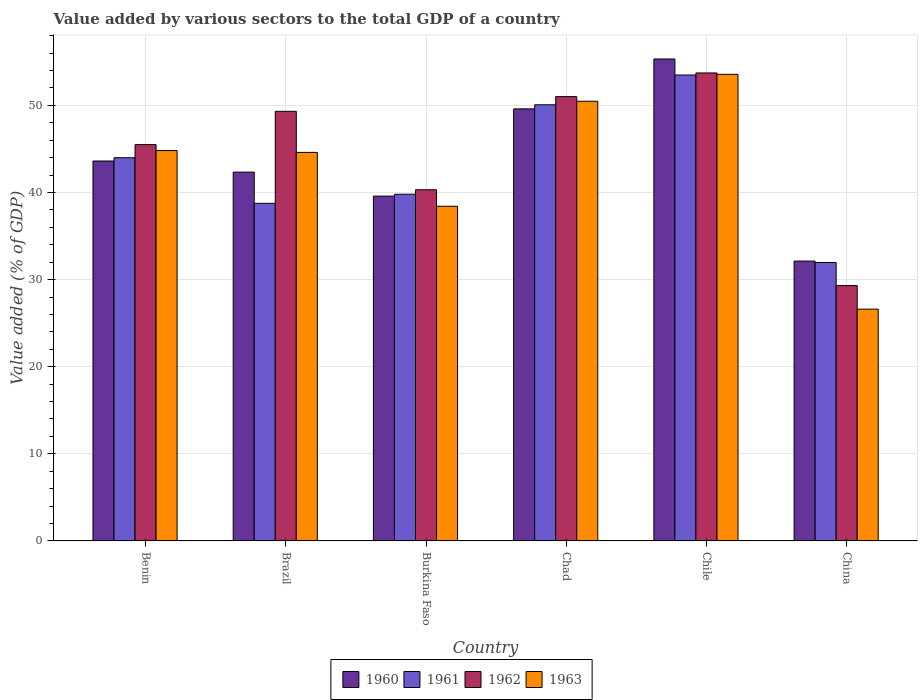How many different coloured bars are there?
Provide a succinct answer. 4. How many groups of bars are there?
Offer a very short reply. 6. Are the number of bars per tick equal to the number of legend labels?
Provide a short and direct response. Yes. Are the number of bars on each tick of the X-axis equal?
Offer a very short reply. Yes. How many bars are there on the 4th tick from the left?
Keep it short and to the point. 4. How many bars are there on the 4th tick from the right?
Your answer should be compact. 4. What is the label of the 4th group of bars from the left?
Provide a short and direct response. Chad. What is the value added by various sectors to the total GDP in 1963 in Benin?
Provide a succinct answer. 44.81. Across all countries, what is the maximum value added by various sectors to the total GDP in 1962?
Your answer should be very brief. 53.72. Across all countries, what is the minimum value added by various sectors to the total GDP in 1962?
Give a very brief answer. 29.31. In which country was the value added by various sectors to the total GDP in 1960 maximum?
Your response must be concise. Chile. What is the total value added by various sectors to the total GDP in 1962 in the graph?
Your answer should be compact. 269.18. What is the difference between the value added by various sectors to the total GDP in 1961 in Brazil and that in China?
Offer a very short reply. 6.79. What is the difference between the value added by various sectors to the total GDP in 1960 in Chad and the value added by various sectors to the total GDP in 1963 in Burkina Faso?
Provide a short and direct response. 11.18. What is the average value added by various sectors to the total GDP in 1960 per country?
Provide a short and direct response. 43.77. What is the difference between the value added by various sectors to the total GDP of/in 1962 and value added by various sectors to the total GDP of/in 1960 in Brazil?
Keep it short and to the point. 6.98. In how many countries, is the value added by various sectors to the total GDP in 1962 greater than 44 %?
Offer a very short reply. 4. What is the ratio of the value added by various sectors to the total GDP in 1961 in Brazil to that in Chad?
Keep it short and to the point. 0.77. Is the value added by various sectors to the total GDP in 1963 in Benin less than that in Brazil?
Ensure brevity in your answer.  No. Is the difference between the value added by various sectors to the total GDP in 1962 in Brazil and China greater than the difference between the value added by various sectors to the total GDP in 1960 in Brazil and China?
Offer a terse response. Yes. What is the difference between the highest and the second highest value added by various sectors to the total GDP in 1963?
Keep it short and to the point. 5.66. What is the difference between the highest and the lowest value added by various sectors to the total GDP in 1960?
Offer a very short reply. 23.2. In how many countries, is the value added by various sectors to the total GDP in 1960 greater than the average value added by various sectors to the total GDP in 1960 taken over all countries?
Ensure brevity in your answer.  2. Is the sum of the value added by various sectors to the total GDP in 1962 in Brazil and Chile greater than the maximum value added by various sectors to the total GDP in 1961 across all countries?
Your answer should be very brief. Yes. What does the 4th bar from the left in Brazil represents?
Your answer should be very brief. 1963. How many bars are there?
Give a very brief answer. 24. Are all the bars in the graph horizontal?
Provide a short and direct response. No. How many countries are there in the graph?
Provide a short and direct response. 6. What is the difference between two consecutive major ticks on the Y-axis?
Keep it short and to the point. 10. Where does the legend appear in the graph?
Provide a succinct answer. Bottom center. How many legend labels are there?
Your answer should be compact. 4. How are the legend labels stacked?
Your response must be concise. Horizontal. What is the title of the graph?
Your answer should be very brief. Value added by various sectors to the total GDP of a country. What is the label or title of the X-axis?
Give a very brief answer. Country. What is the label or title of the Y-axis?
Your answer should be compact. Value added (% of GDP). What is the Value added (% of GDP) in 1960 in Benin?
Provide a short and direct response. 43.62. What is the Value added (% of GDP) in 1961 in Benin?
Give a very brief answer. 43.99. What is the Value added (% of GDP) of 1962 in Benin?
Your answer should be very brief. 45.5. What is the Value added (% of GDP) of 1963 in Benin?
Ensure brevity in your answer.  44.81. What is the Value added (% of GDP) of 1960 in Brazil?
Give a very brief answer. 42.34. What is the Value added (% of GDP) of 1961 in Brazil?
Your response must be concise. 38.76. What is the Value added (% of GDP) in 1962 in Brazil?
Give a very brief answer. 49.32. What is the Value added (% of GDP) of 1963 in Brazil?
Provide a succinct answer. 44.6. What is the Value added (% of GDP) of 1960 in Burkina Faso?
Make the answer very short. 39.59. What is the Value added (% of GDP) in 1961 in Burkina Faso?
Provide a succinct answer. 39.8. What is the Value added (% of GDP) of 1962 in Burkina Faso?
Provide a succinct answer. 40.31. What is the Value added (% of GDP) of 1963 in Burkina Faso?
Your answer should be compact. 38.42. What is the Value added (% of GDP) of 1960 in Chad?
Provide a short and direct response. 49.6. What is the Value added (% of GDP) of 1961 in Chad?
Give a very brief answer. 50.07. What is the Value added (% of GDP) of 1962 in Chad?
Offer a terse response. 51.01. What is the Value added (% of GDP) in 1963 in Chad?
Your answer should be compact. 50.47. What is the Value added (% of GDP) in 1960 in Chile?
Make the answer very short. 55.33. What is the Value added (% of GDP) in 1961 in Chile?
Your response must be concise. 53.49. What is the Value added (% of GDP) in 1962 in Chile?
Offer a very short reply. 53.72. What is the Value added (% of GDP) of 1963 in Chile?
Make the answer very short. 53.57. What is the Value added (% of GDP) of 1960 in China?
Your response must be concise. 32.13. What is the Value added (% of GDP) in 1961 in China?
Your response must be concise. 31.97. What is the Value added (% of GDP) of 1962 in China?
Provide a succinct answer. 29.31. What is the Value added (% of GDP) of 1963 in China?
Provide a short and direct response. 26.61. Across all countries, what is the maximum Value added (% of GDP) of 1960?
Provide a short and direct response. 55.33. Across all countries, what is the maximum Value added (% of GDP) of 1961?
Make the answer very short. 53.49. Across all countries, what is the maximum Value added (% of GDP) of 1962?
Make the answer very short. 53.72. Across all countries, what is the maximum Value added (% of GDP) in 1963?
Give a very brief answer. 53.57. Across all countries, what is the minimum Value added (% of GDP) in 1960?
Offer a very short reply. 32.13. Across all countries, what is the minimum Value added (% of GDP) in 1961?
Your answer should be compact. 31.97. Across all countries, what is the minimum Value added (% of GDP) in 1962?
Your response must be concise. 29.31. Across all countries, what is the minimum Value added (% of GDP) in 1963?
Your response must be concise. 26.61. What is the total Value added (% of GDP) of 1960 in the graph?
Provide a short and direct response. 262.6. What is the total Value added (% of GDP) in 1961 in the graph?
Your answer should be compact. 258.07. What is the total Value added (% of GDP) of 1962 in the graph?
Your response must be concise. 269.18. What is the total Value added (% of GDP) in 1963 in the graph?
Provide a short and direct response. 258.49. What is the difference between the Value added (% of GDP) of 1960 in Benin and that in Brazil?
Offer a very short reply. 1.27. What is the difference between the Value added (% of GDP) in 1961 in Benin and that in Brazil?
Make the answer very short. 5.23. What is the difference between the Value added (% of GDP) in 1962 in Benin and that in Brazil?
Ensure brevity in your answer.  -3.82. What is the difference between the Value added (% of GDP) in 1963 in Benin and that in Brazil?
Provide a succinct answer. 0.21. What is the difference between the Value added (% of GDP) of 1960 in Benin and that in Burkina Faso?
Ensure brevity in your answer.  4.03. What is the difference between the Value added (% of GDP) in 1961 in Benin and that in Burkina Faso?
Offer a terse response. 4.19. What is the difference between the Value added (% of GDP) of 1962 in Benin and that in Burkina Faso?
Make the answer very short. 5.19. What is the difference between the Value added (% of GDP) of 1963 in Benin and that in Burkina Faso?
Provide a short and direct response. 6.39. What is the difference between the Value added (% of GDP) of 1960 in Benin and that in Chad?
Offer a terse response. -5.98. What is the difference between the Value added (% of GDP) of 1961 in Benin and that in Chad?
Your response must be concise. -6.08. What is the difference between the Value added (% of GDP) in 1962 in Benin and that in Chad?
Keep it short and to the point. -5.51. What is the difference between the Value added (% of GDP) of 1963 in Benin and that in Chad?
Provide a short and direct response. -5.66. What is the difference between the Value added (% of GDP) in 1960 in Benin and that in Chile?
Provide a succinct answer. -11.71. What is the difference between the Value added (% of GDP) of 1961 in Benin and that in Chile?
Your response must be concise. -9.49. What is the difference between the Value added (% of GDP) of 1962 in Benin and that in Chile?
Ensure brevity in your answer.  -8.22. What is the difference between the Value added (% of GDP) of 1963 in Benin and that in Chile?
Offer a very short reply. -8.75. What is the difference between the Value added (% of GDP) of 1960 in Benin and that in China?
Your response must be concise. 11.49. What is the difference between the Value added (% of GDP) in 1961 in Benin and that in China?
Provide a short and direct response. 12.03. What is the difference between the Value added (% of GDP) in 1962 in Benin and that in China?
Your answer should be compact. 16.19. What is the difference between the Value added (% of GDP) of 1963 in Benin and that in China?
Offer a very short reply. 18.2. What is the difference between the Value added (% of GDP) of 1960 in Brazil and that in Burkina Faso?
Ensure brevity in your answer.  2.75. What is the difference between the Value added (% of GDP) of 1961 in Brazil and that in Burkina Faso?
Give a very brief answer. -1.04. What is the difference between the Value added (% of GDP) of 1962 in Brazil and that in Burkina Faso?
Your answer should be compact. 9.01. What is the difference between the Value added (% of GDP) of 1963 in Brazil and that in Burkina Faso?
Keep it short and to the point. 6.19. What is the difference between the Value added (% of GDP) of 1960 in Brazil and that in Chad?
Keep it short and to the point. -7.26. What is the difference between the Value added (% of GDP) of 1961 in Brazil and that in Chad?
Offer a terse response. -11.31. What is the difference between the Value added (% of GDP) of 1962 in Brazil and that in Chad?
Ensure brevity in your answer.  -1.69. What is the difference between the Value added (% of GDP) of 1963 in Brazil and that in Chad?
Keep it short and to the point. -5.87. What is the difference between the Value added (% of GDP) of 1960 in Brazil and that in Chile?
Make the answer very short. -12.99. What is the difference between the Value added (% of GDP) in 1961 in Brazil and that in Chile?
Provide a succinct answer. -14.73. What is the difference between the Value added (% of GDP) of 1962 in Brazil and that in Chile?
Ensure brevity in your answer.  -4.4. What is the difference between the Value added (% of GDP) in 1963 in Brazil and that in Chile?
Ensure brevity in your answer.  -8.96. What is the difference between the Value added (% of GDP) of 1960 in Brazil and that in China?
Make the answer very short. 10.21. What is the difference between the Value added (% of GDP) in 1961 in Brazil and that in China?
Keep it short and to the point. 6.79. What is the difference between the Value added (% of GDP) of 1962 in Brazil and that in China?
Offer a terse response. 20.01. What is the difference between the Value added (% of GDP) in 1963 in Brazil and that in China?
Provide a succinct answer. 17.99. What is the difference between the Value added (% of GDP) in 1960 in Burkina Faso and that in Chad?
Offer a very short reply. -10.01. What is the difference between the Value added (% of GDP) in 1961 in Burkina Faso and that in Chad?
Your answer should be very brief. -10.27. What is the difference between the Value added (% of GDP) of 1962 in Burkina Faso and that in Chad?
Offer a very short reply. -10.69. What is the difference between the Value added (% of GDP) in 1963 in Burkina Faso and that in Chad?
Offer a very short reply. -12.06. What is the difference between the Value added (% of GDP) of 1960 in Burkina Faso and that in Chile?
Keep it short and to the point. -15.74. What is the difference between the Value added (% of GDP) of 1961 in Burkina Faso and that in Chile?
Provide a succinct answer. -13.69. What is the difference between the Value added (% of GDP) in 1962 in Burkina Faso and that in Chile?
Your response must be concise. -13.41. What is the difference between the Value added (% of GDP) of 1963 in Burkina Faso and that in Chile?
Your answer should be compact. -15.15. What is the difference between the Value added (% of GDP) of 1960 in Burkina Faso and that in China?
Keep it short and to the point. 7.46. What is the difference between the Value added (% of GDP) in 1961 in Burkina Faso and that in China?
Your response must be concise. 7.83. What is the difference between the Value added (% of GDP) of 1962 in Burkina Faso and that in China?
Your response must be concise. 11. What is the difference between the Value added (% of GDP) in 1963 in Burkina Faso and that in China?
Your answer should be very brief. 11.81. What is the difference between the Value added (% of GDP) of 1960 in Chad and that in Chile?
Your answer should be compact. -5.73. What is the difference between the Value added (% of GDP) of 1961 in Chad and that in Chile?
Offer a very short reply. -3.42. What is the difference between the Value added (% of GDP) in 1962 in Chad and that in Chile?
Offer a very short reply. -2.72. What is the difference between the Value added (% of GDP) in 1963 in Chad and that in Chile?
Ensure brevity in your answer.  -3.09. What is the difference between the Value added (% of GDP) of 1960 in Chad and that in China?
Provide a short and direct response. 17.47. What is the difference between the Value added (% of GDP) of 1961 in Chad and that in China?
Provide a short and direct response. 18.1. What is the difference between the Value added (% of GDP) of 1962 in Chad and that in China?
Offer a very short reply. 21.69. What is the difference between the Value added (% of GDP) in 1963 in Chad and that in China?
Your answer should be compact. 23.86. What is the difference between the Value added (% of GDP) of 1960 in Chile and that in China?
Ensure brevity in your answer.  23.2. What is the difference between the Value added (% of GDP) in 1961 in Chile and that in China?
Offer a terse response. 21.52. What is the difference between the Value added (% of GDP) in 1962 in Chile and that in China?
Make the answer very short. 24.41. What is the difference between the Value added (% of GDP) in 1963 in Chile and that in China?
Provide a succinct answer. 26.96. What is the difference between the Value added (% of GDP) in 1960 in Benin and the Value added (% of GDP) in 1961 in Brazil?
Provide a succinct answer. 4.86. What is the difference between the Value added (% of GDP) in 1960 in Benin and the Value added (% of GDP) in 1962 in Brazil?
Offer a terse response. -5.71. What is the difference between the Value added (% of GDP) in 1960 in Benin and the Value added (% of GDP) in 1963 in Brazil?
Keep it short and to the point. -0.99. What is the difference between the Value added (% of GDP) of 1961 in Benin and the Value added (% of GDP) of 1962 in Brazil?
Your answer should be compact. -5.33. What is the difference between the Value added (% of GDP) of 1961 in Benin and the Value added (% of GDP) of 1963 in Brazil?
Provide a short and direct response. -0.61. What is the difference between the Value added (% of GDP) of 1962 in Benin and the Value added (% of GDP) of 1963 in Brazil?
Provide a short and direct response. 0.89. What is the difference between the Value added (% of GDP) of 1960 in Benin and the Value added (% of GDP) of 1961 in Burkina Faso?
Offer a terse response. 3.82. What is the difference between the Value added (% of GDP) in 1960 in Benin and the Value added (% of GDP) in 1962 in Burkina Faso?
Your response must be concise. 3.3. What is the difference between the Value added (% of GDP) in 1960 in Benin and the Value added (% of GDP) in 1963 in Burkina Faso?
Offer a very short reply. 5.2. What is the difference between the Value added (% of GDP) of 1961 in Benin and the Value added (% of GDP) of 1962 in Burkina Faso?
Offer a very short reply. 3.68. What is the difference between the Value added (% of GDP) of 1961 in Benin and the Value added (% of GDP) of 1963 in Burkina Faso?
Give a very brief answer. 5.57. What is the difference between the Value added (% of GDP) in 1962 in Benin and the Value added (% of GDP) in 1963 in Burkina Faso?
Give a very brief answer. 7.08. What is the difference between the Value added (% of GDP) of 1960 in Benin and the Value added (% of GDP) of 1961 in Chad?
Make the answer very short. -6.45. What is the difference between the Value added (% of GDP) of 1960 in Benin and the Value added (% of GDP) of 1962 in Chad?
Your answer should be very brief. -7.39. What is the difference between the Value added (% of GDP) in 1960 in Benin and the Value added (% of GDP) in 1963 in Chad?
Provide a succinct answer. -6.86. What is the difference between the Value added (% of GDP) of 1961 in Benin and the Value added (% of GDP) of 1962 in Chad?
Keep it short and to the point. -7.01. What is the difference between the Value added (% of GDP) in 1961 in Benin and the Value added (% of GDP) in 1963 in Chad?
Your response must be concise. -6.48. What is the difference between the Value added (% of GDP) of 1962 in Benin and the Value added (% of GDP) of 1963 in Chad?
Give a very brief answer. -4.98. What is the difference between the Value added (% of GDP) of 1960 in Benin and the Value added (% of GDP) of 1961 in Chile?
Offer a very short reply. -9.87. What is the difference between the Value added (% of GDP) of 1960 in Benin and the Value added (% of GDP) of 1962 in Chile?
Your response must be concise. -10.11. What is the difference between the Value added (% of GDP) of 1960 in Benin and the Value added (% of GDP) of 1963 in Chile?
Ensure brevity in your answer.  -9.95. What is the difference between the Value added (% of GDP) of 1961 in Benin and the Value added (% of GDP) of 1962 in Chile?
Give a very brief answer. -9.73. What is the difference between the Value added (% of GDP) in 1961 in Benin and the Value added (% of GDP) in 1963 in Chile?
Give a very brief answer. -9.57. What is the difference between the Value added (% of GDP) of 1962 in Benin and the Value added (% of GDP) of 1963 in Chile?
Your answer should be very brief. -8.07. What is the difference between the Value added (% of GDP) in 1960 in Benin and the Value added (% of GDP) in 1961 in China?
Make the answer very short. 11.65. What is the difference between the Value added (% of GDP) of 1960 in Benin and the Value added (% of GDP) of 1962 in China?
Provide a succinct answer. 14.3. What is the difference between the Value added (% of GDP) in 1960 in Benin and the Value added (% of GDP) in 1963 in China?
Make the answer very short. 17. What is the difference between the Value added (% of GDP) in 1961 in Benin and the Value added (% of GDP) in 1962 in China?
Offer a terse response. 14.68. What is the difference between the Value added (% of GDP) in 1961 in Benin and the Value added (% of GDP) in 1963 in China?
Provide a succinct answer. 17.38. What is the difference between the Value added (% of GDP) of 1962 in Benin and the Value added (% of GDP) of 1963 in China?
Offer a terse response. 18.89. What is the difference between the Value added (% of GDP) in 1960 in Brazil and the Value added (% of GDP) in 1961 in Burkina Faso?
Provide a short and direct response. 2.54. What is the difference between the Value added (% of GDP) of 1960 in Brazil and the Value added (% of GDP) of 1962 in Burkina Faso?
Give a very brief answer. 2.03. What is the difference between the Value added (% of GDP) in 1960 in Brazil and the Value added (% of GDP) in 1963 in Burkina Faso?
Your response must be concise. 3.92. What is the difference between the Value added (% of GDP) in 1961 in Brazil and the Value added (% of GDP) in 1962 in Burkina Faso?
Offer a very short reply. -1.55. What is the difference between the Value added (% of GDP) in 1961 in Brazil and the Value added (% of GDP) in 1963 in Burkina Faso?
Your response must be concise. 0.34. What is the difference between the Value added (% of GDP) of 1962 in Brazil and the Value added (% of GDP) of 1963 in Burkina Faso?
Your answer should be compact. 10.9. What is the difference between the Value added (% of GDP) of 1960 in Brazil and the Value added (% of GDP) of 1961 in Chad?
Keep it short and to the point. -7.73. What is the difference between the Value added (% of GDP) in 1960 in Brazil and the Value added (% of GDP) in 1962 in Chad?
Provide a succinct answer. -8.67. What is the difference between the Value added (% of GDP) of 1960 in Brazil and the Value added (% of GDP) of 1963 in Chad?
Ensure brevity in your answer.  -8.13. What is the difference between the Value added (% of GDP) in 1961 in Brazil and the Value added (% of GDP) in 1962 in Chad?
Your answer should be compact. -12.25. What is the difference between the Value added (% of GDP) in 1961 in Brazil and the Value added (% of GDP) in 1963 in Chad?
Ensure brevity in your answer.  -11.72. What is the difference between the Value added (% of GDP) in 1962 in Brazil and the Value added (% of GDP) in 1963 in Chad?
Your answer should be compact. -1.15. What is the difference between the Value added (% of GDP) of 1960 in Brazil and the Value added (% of GDP) of 1961 in Chile?
Ensure brevity in your answer.  -11.14. What is the difference between the Value added (% of GDP) in 1960 in Brazil and the Value added (% of GDP) in 1962 in Chile?
Ensure brevity in your answer.  -11.38. What is the difference between the Value added (% of GDP) of 1960 in Brazil and the Value added (% of GDP) of 1963 in Chile?
Your answer should be compact. -11.23. What is the difference between the Value added (% of GDP) in 1961 in Brazil and the Value added (% of GDP) in 1962 in Chile?
Keep it short and to the point. -14.97. What is the difference between the Value added (% of GDP) in 1961 in Brazil and the Value added (% of GDP) in 1963 in Chile?
Make the answer very short. -14.81. What is the difference between the Value added (% of GDP) of 1962 in Brazil and the Value added (% of GDP) of 1963 in Chile?
Make the answer very short. -4.25. What is the difference between the Value added (% of GDP) of 1960 in Brazil and the Value added (% of GDP) of 1961 in China?
Provide a succinct answer. 10.37. What is the difference between the Value added (% of GDP) of 1960 in Brazil and the Value added (% of GDP) of 1962 in China?
Ensure brevity in your answer.  13.03. What is the difference between the Value added (% of GDP) in 1960 in Brazil and the Value added (% of GDP) in 1963 in China?
Give a very brief answer. 15.73. What is the difference between the Value added (% of GDP) in 1961 in Brazil and the Value added (% of GDP) in 1962 in China?
Ensure brevity in your answer.  9.44. What is the difference between the Value added (% of GDP) of 1961 in Brazil and the Value added (% of GDP) of 1963 in China?
Offer a very short reply. 12.15. What is the difference between the Value added (% of GDP) of 1962 in Brazil and the Value added (% of GDP) of 1963 in China?
Your answer should be compact. 22.71. What is the difference between the Value added (% of GDP) in 1960 in Burkina Faso and the Value added (% of GDP) in 1961 in Chad?
Make the answer very short. -10.48. What is the difference between the Value added (% of GDP) of 1960 in Burkina Faso and the Value added (% of GDP) of 1962 in Chad?
Ensure brevity in your answer.  -11.42. What is the difference between the Value added (% of GDP) of 1960 in Burkina Faso and the Value added (% of GDP) of 1963 in Chad?
Ensure brevity in your answer.  -10.89. What is the difference between the Value added (% of GDP) in 1961 in Burkina Faso and the Value added (% of GDP) in 1962 in Chad?
Your response must be concise. -11.21. What is the difference between the Value added (% of GDP) in 1961 in Burkina Faso and the Value added (% of GDP) in 1963 in Chad?
Offer a very short reply. -10.68. What is the difference between the Value added (% of GDP) in 1962 in Burkina Faso and the Value added (% of GDP) in 1963 in Chad?
Make the answer very short. -10.16. What is the difference between the Value added (% of GDP) in 1960 in Burkina Faso and the Value added (% of GDP) in 1961 in Chile?
Your answer should be very brief. -13.9. What is the difference between the Value added (% of GDP) of 1960 in Burkina Faso and the Value added (% of GDP) of 1962 in Chile?
Give a very brief answer. -14.14. What is the difference between the Value added (% of GDP) in 1960 in Burkina Faso and the Value added (% of GDP) in 1963 in Chile?
Make the answer very short. -13.98. What is the difference between the Value added (% of GDP) of 1961 in Burkina Faso and the Value added (% of GDP) of 1962 in Chile?
Offer a terse response. -13.92. What is the difference between the Value added (% of GDP) in 1961 in Burkina Faso and the Value added (% of GDP) in 1963 in Chile?
Keep it short and to the point. -13.77. What is the difference between the Value added (% of GDP) of 1962 in Burkina Faso and the Value added (% of GDP) of 1963 in Chile?
Provide a succinct answer. -13.25. What is the difference between the Value added (% of GDP) of 1960 in Burkina Faso and the Value added (% of GDP) of 1961 in China?
Offer a terse response. 7.62. What is the difference between the Value added (% of GDP) in 1960 in Burkina Faso and the Value added (% of GDP) in 1962 in China?
Offer a very short reply. 10.27. What is the difference between the Value added (% of GDP) in 1960 in Burkina Faso and the Value added (% of GDP) in 1963 in China?
Give a very brief answer. 12.97. What is the difference between the Value added (% of GDP) in 1961 in Burkina Faso and the Value added (% of GDP) in 1962 in China?
Give a very brief answer. 10.49. What is the difference between the Value added (% of GDP) of 1961 in Burkina Faso and the Value added (% of GDP) of 1963 in China?
Provide a short and direct response. 13.19. What is the difference between the Value added (% of GDP) in 1962 in Burkina Faso and the Value added (% of GDP) in 1963 in China?
Your response must be concise. 13.7. What is the difference between the Value added (% of GDP) of 1960 in Chad and the Value added (% of GDP) of 1961 in Chile?
Offer a very short reply. -3.89. What is the difference between the Value added (% of GDP) of 1960 in Chad and the Value added (% of GDP) of 1962 in Chile?
Provide a succinct answer. -4.13. What is the difference between the Value added (% of GDP) of 1960 in Chad and the Value added (% of GDP) of 1963 in Chile?
Provide a short and direct response. -3.97. What is the difference between the Value added (% of GDP) in 1961 in Chad and the Value added (% of GDP) in 1962 in Chile?
Your answer should be very brief. -3.66. What is the difference between the Value added (% of GDP) of 1961 in Chad and the Value added (% of GDP) of 1963 in Chile?
Provide a short and direct response. -3.5. What is the difference between the Value added (% of GDP) of 1962 in Chad and the Value added (% of GDP) of 1963 in Chile?
Your response must be concise. -2.56. What is the difference between the Value added (% of GDP) in 1960 in Chad and the Value added (% of GDP) in 1961 in China?
Keep it short and to the point. 17.63. What is the difference between the Value added (% of GDP) in 1960 in Chad and the Value added (% of GDP) in 1962 in China?
Keep it short and to the point. 20.29. What is the difference between the Value added (% of GDP) in 1960 in Chad and the Value added (% of GDP) in 1963 in China?
Your response must be concise. 22.99. What is the difference between the Value added (% of GDP) in 1961 in Chad and the Value added (% of GDP) in 1962 in China?
Give a very brief answer. 20.76. What is the difference between the Value added (% of GDP) in 1961 in Chad and the Value added (% of GDP) in 1963 in China?
Provide a short and direct response. 23.46. What is the difference between the Value added (% of GDP) of 1962 in Chad and the Value added (% of GDP) of 1963 in China?
Offer a very short reply. 24.39. What is the difference between the Value added (% of GDP) of 1960 in Chile and the Value added (% of GDP) of 1961 in China?
Your response must be concise. 23.36. What is the difference between the Value added (% of GDP) in 1960 in Chile and the Value added (% of GDP) in 1962 in China?
Give a very brief answer. 26.02. What is the difference between the Value added (% of GDP) of 1960 in Chile and the Value added (% of GDP) of 1963 in China?
Ensure brevity in your answer.  28.72. What is the difference between the Value added (% of GDP) in 1961 in Chile and the Value added (% of GDP) in 1962 in China?
Offer a very short reply. 24.17. What is the difference between the Value added (% of GDP) in 1961 in Chile and the Value added (% of GDP) in 1963 in China?
Your response must be concise. 26.87. What is the difference between the Value added (% of GDP) of 1962 in Chile and the Value added (% of GDP) of 1963 in China?
Provide a short and direct response. 27.11. What is the average Value added (% of GDP) in 1960 per country?
Provide a short and direct response. 43.77. What is the average Value added (% of GDP) of 1961 per country?
Give a very brief answer. 43.01. What is the average Value added (% of GDP) of 1962 per country?
Keep it short and to the point. 44.86. What is the average Value added (% of GDP) in 1963 per country?
Your response must be concise. 43.08. What is the difference between the Value added (% of GDP) of 1960 and Value added (% of GDP) of 1961 in Benin?
Ensure brevity in your answer.  -0.38. What is the difference between the Value added (% of GDP) of 1960 and Value added (% of GDP) of 1962 in Benin?
Offer a terse response. -1.88. What is the difference between the Value added (% of GDP) of 1960 and Value added (% of GDP) of 1963 in Benin?
Make the answer very short. -1.2. What is the difference between the Value added (% of GDP) of 1961 and Value added (% of GDP) of 1962 in Benin?
Make the answer very short. -1.51. What is the difference between the Value added (% of GDP) of 1961 and Value added (% of GDP) of 1963 in Benin?
Provide a succinct answer. -0.82. What is the difference between the Value added (% of GDP) in 1962 and Value added (% of GDP) in 1963 in Benin?
Provide a succinct answer. 0.69. What is the difference between the Value added (% of GDP) in 1960 and Value added (% of GDP) in 1961 in Brazil?
Your response must be concise. 3.58. What is the difference between the Value added (% of GDP) of 1960 and Value added (% of GDP) of 1962 in Brazil?
Offer a very short reply. -6.98. What is the difference between the Value added (% of GDP) of 1960 and Value added (% of GDP) of 1963 in Brazil?
Keep it short and to the point. -2.26. What is the difference between the Value added (% of GDP) in 1961 and Value added (% of GDP) in 1962 in Brazil?
Provide a succinct answer. -10.56. What is the difference between the Value added (% of GDP) in 1961 and Value added (% of GDP) in 1963 in Brazil?
Ensure brevity in your answer.  -5.85. What is the difference between the Value added (% of GDP) of 1962 and Value added (% of GDP) of 1963 in Brazil?
Keep it short and to the point. 4.72. What is the difference between the Value added (% of GDP) in 1960 and Value added (% of GDP) in 1961 in Burkina Faso?
Your answer should be compact. -0.21. What is the difference between the Value added (% of GDP) of 1960 and Value added (% of GDP) of 1962 in Burkina Faso?
Offer a terse response. -0.73. What is the difference between the Value added (% of GDP) in 1960 and Value added (% of GDP) in 1963 in Burkina Faso?
Provide a succinct answer. 1.17. What is the difference between the Value added (% of GDP) in 1961 and Value added (% of GDP) in 1962 in Burkina Faso?
Ensure brevity in your answer.  -0.51. What is the difference between the Value added (% of GDP) of 1961 and Value added (% of GDP) of 1963 in Burkina Faso?
Provide a short and direct response. 1.38. What is the difference between the Value added (% of GDP) in 1962 and Value added (% of GDP) in 1963 in Burkina Faso?
Offer a terse response. 1.89. What is the difference between the Value added (% of GDP) of 1960 and Value added (% of GDP) of 1961 in Chad?
Provide a succinct answer. -0.47. What is the difference between the Value added (% of GDP) in 1960 and Value added (% of GDP) in 1962 in Chad?
Your answer should be compact. -1.41. What is the difference between the Value added (% of GDP) of 1960 and Value added (% of GDP) of 1963 in Chad?
Provide a short and direct response. -0.88. What is the difference between the Value added (% of GDP) in 1961 and Value added (% of GDP) in 1962 in Chad?
Make the answer very short. -0.94. What is the difference between the Value added (% of GDP) of 1961 and Value added (% of GDP) of 1963 in Chad?
Your response must be concise. -0.41. What is the difference between the Value added (% of GDP) in 1962 and Value added (% of GDP) in 1963 in Chad?
Give a very brief answer. 0.53. What is the difference between the Value added (% of GDP) of 1960 and Value added (% of GDP) of 1961 in Chile?
Ensure brevity in your answer.  1.84. What is the difference between the Value added (% of GDP) in 1960 and Value added (% of GDP) in 1962 in Chile?
Your response must be concise. 1.6. What is the difference between the Value added (% of GDP) in 1960 and Value added (% of GDP) in 1963 in Chile?
Give a very brief answer. 1.76. What is the difference between the Value added (% of GDP) of 1961 and Value added (% of GDP) of 1962 in Chile?
Offer a very short reply. -0.24. What is the difference between the Value added (% of GDP) in 1961 and Value added (% of GDP) in 1963 in Chile?
Provide a succinct answer. -0.08. What is the difference between the Value added (% of GDP) of 1962 and Value added (% of GDP) of 1963 in Chile?
Make the answer very short. 0.16. What is the difference between the Value added (% of GDP) of 1960 and Value added (% of GDP) of 1961 in China?
Provide a succinct answer. 0.16. What is the difference between the Value added (% of GDP) in 1960 and Value added (% of GDP) in 1962 in China?
Offer a very short reply. 2.81. What is the difference between the Value added (% of GDP) of 1960 and Value added (% of GDP) of 1963 in China?
Your answer should be very brief. 5.52. What is the difference between the Value added (% of GDP) in 1961 and Value added (% of GDP) in 1962 in China?
Your answer should be very brief. 2.65. What is the difference between the Value added (% of GDP) in 1961 and Value added (% of GDP) in 1963 in China?
Make the answer very short. 5.36. What is the difference between the Value added (% of GDP) of 1962 and Value added (% of GDP) of 1963 in China?
Your answer should be compact. 2.7. What is the ratio of the Value added (% of GDP) in 1960 in Benin to that in Brazil?
Your answer should be very brief. 1.03. What is the ratio of the Value added (% of GDP) in 1961 in Benin to that in Brazil?
Your answer should be very brief. 1.14. What is the ratio of the Value added (% of GDP) of 1962 in Benin to that in Brazil?
Ensure brevity in your answer.  0.92. What is the ratio of the Value added (% of GDP) in 1960 in Benin to that in Burkina Faso?
Your answer should be very brief. 1.1. What is the ratio of the Value added (% of GDP) of 1961 in Benin to that in Burkina Faso?
Make the answer very short. 1.11. What is the ratio of the Value added (% of GDP) of 1962 in Benin to that in Burkina Faso?
Your response must be concise. 1.13. What is the ratio of the Value added (% of GDP) of 1963 in Benin to that in Burkina Faso?
Ensure brevity in your answer.  1.17. What is the ratio of the Value added (% of GDP) in 1960 in Benin to that in Chad?
Offer a terse response. 0.88. What is the ratio of the Value added (% of GDP) of 1961 in Benin to that in Chad?
Ensure brevity in your answer.  0.88. What is the ratio of the Value added (% of GDP) in 1962 in Benin to that in Chad?
Your answer should be very brief. 0.89. What is the ratio of the Value added (% of GDP) of 1963 in Benin to that in Chad?
Your response must be concise. 0.89. What is the ratio of the Value added (% of GDP) of 1960 in Benin to that in Chile?
Keep it short and to the point. 0.79. What is the ratio of the Value added (% of GDP) of 1961 in Benin to that in Chile?
Keep it short and to the point. 0.82. What is the ratio of the Value added (% of GDP) of 1962 in Benin to that in Chile?
Keep it short and to the point. 0.85. What is the ratio of the Value added (% of GDP) in 1963 in Benin to that in Chile?
Offer a very short reply. 0.84. What is the ratio of the Value added (% of GDP) in 1960 in Benin to that in China?
Keep it short and to the point. 1.36. What is the ratio of the Value added (% of GDP) in 1961 in Benin to that in China?
Offer a terse response. 1.38. What is the ratio of the Value added (% of GDP) in 1962 in Benin to that in China?
Give a very brief answer. 1.55. What is the ratio of the Value added (% of GDP) of 1963 in Benin to that in China?
Offer a very short reply. 1.68. What is the ratio of the Value added (% of GDP) of 1960 in Brazil to that in Burkina Faso?
Provide a succinct answer. 1.07. What is the ratio of the Value added (% of GDP) in 1961 in Brazil to that in Burkina Faso?
Offer a terse response. 0.97. What is the ratio of the Value added (% of GDP) of 1962 in Brazil to that in Burkina Faso?
Ensure brevity in your answer.  1.22. What is the ratio of the Value added (% of GDP) in 1963 in Brazil to that in Burkina Faso?
Offer a terse response. 1.16. What is the ratio of the Value added (% of GDP) of 1960 in Brazil to that in Chad?
Keep it short and to the point. 0.85. What is the ratio of the Value added (% of GDP) in 1961 in Brazil to that in Chad?
Your answer should be very brief. 0.77. What is the ratio of the Value added (% of GDP) of 1963 in Brazil to that in Chad?
Your answer should be compact. 0.88. What is the ratio of the Value added (% of GDP) in 1960 in Brazil to that in Chile?
Ensure brevity in your answer.  0.77. What is the ratio of the Value added (% of GDP) of 1961 in Brazil to that in Chile?
Give a very brief answer. 0.72. What is the ratio of the Value added (% of GDP) of 1962 in Brazil to that in Chile?
Offer a very short reply. 0.92. What is the ratio of the Value added (% of GDP) in 1963 in Brazil to that in Chile?
Provide a short and direct response. 0.83. What is the ratio of the Value added (% of GDP) in 1960 in Brazil to that in China?
Provide a succinct answer. 1.32. What is the ratio of the Value added (% of GDP) in 1961 in Brazil to that in China?
Provide a short and direct response. 1.21. What is the ratio of the Value added (% of GDP) in 1962 in Brazil to that in China?
Give a very brief answer. 1.68. What is the ratio of the Value added (% of GDP) of 1963 in Brazil to that in China?
Keep it short and to the point. 1.68. What is the ratio of the Value added (% of GDP) of 1960 in Burkina Faso to that in Chad?
Provide a short and direct response. 0.8. What is the ratio of the Value added (% of GDP) of 1961 in Burkina Faso to that in Chad?
Ensure brevity in your answer.  0.79. What is the ratio of the Value added (% of GDP) of 1962 in Burkina Faso to that in Chad?
Give a very brief answer. 0.79. What is the ratio of the Value added (% of GDP) of 1963 in Burkina Faso to that in Chad?
Give a very brief answer. 0.76. What is the ratio of the Value added (% of GDP) of 1960 in Burkina Faso to that in Chile?
Your response must be concise. 0.72. What is the ratio of the Value added (% of GDP) in 1961 in Burkina Faso to that in Chile?
Offer a very short reply. 0.74. What is the ratio of the Value added (% of GDP) of 1962 in Burkina Faso to that in Chile?
Your answer should be compact. 0.75. What is the ratio of the Value added (% of GDP) of 1963 in Burkina Faso to that in Chile?
Your answer should be very brief. 0.72. What is the ratio of the Value added (% of GDP) of 1960 in Burkina Faso to that in China?
Your response must be concise. 1.23. What is the ratio of the Value added (% of GDP) of 1961 in Burkina Faso to that in China?
Make the answer very short. 1.25. What is the ratio of the Value added (% of GDP) of 1962 in Burkina Faso to that in China?
Your response must be concise. 1.38. What is the ratio of the Value added (% of GDP) of 1963 in Burkina Faso to that in China?
Your answer should be very brief. 1.44. What is the ratio of the Value added (% of GDP) in 1960 in Chad to that in Chile?
Give a very brief answer. 0.9. What is the ratio of the Value added (% of GDP) of 1961 in Chad to that in Chile?
Offer a terse response. 0.94. What is the ratio of the Value added (% of GDP) of 1962 in Chad to that in Chile?
Offer a terse response. 0.95. What is the ratio of the Value added (% of GDP) of 1963 in Chad to that in Chile?
Provide a short and direct response. 0.94. What is the ratio of the Value added (% of GDP) of 1960 in Chad to that in China?
Your answer should be compact. 1.54. What is the ratio of the Value added (% of GDP) of 1961 in Chad to that in China?
Ensure brevity in your answer.  1.57. What is the ratio of the Value added (% of GDP) in 1962 in Chad to that in China?
Offer a very short reply. 1.74. What is the ratio of the Value added (% of GDP) in 1963 in Chad to that in China?
Your response must be concise. 1.9. What is the ratio of the Value added (% of GDP) in 1960 in Chile to that in China?
Provide a succinct answer. 1.72. What is the ratio of the Value added (% of GDP) in 1961 in Chile to that in China?
Give a very brief answer. 1.67. What is the ratio of the Value added (% of GDP) in 1962 in Chile to that in China?
Offer a terse response. 1.83. What is the ratio of the Value added (% of GDP) of 1963 in Chile to that in China?
Ensure brevity in your answer.  2.01. What is the difference between the highest and the second highest Value added (% of GDP) in 1960?
Provide a succinct answer. 5.73. What is the difference between the highest and the second highest Value added (% of GDP) of 1961?
Make the answer very short. 3.42. What is the difference between the highest and the second highest Value added (% of GDP) of 1962?
Provide a short and direct response. 2.72. What is the difference between the highest and the second highest Value added (% of GDP) of 1963?
Your answer should be very brief. 3.09. What is the difference between the highest and the lowest Value added (% of GDP) of 1960?
Provide a short and direct response. 23.2. What is the difference between the highest and the lowest Value added (% of GDP) in 1961?
Provide a succinct answer. 21.52. What is the difference between the highest and the lowest Value added (% of GDP) of 1962?
Ensure brevity in your answer.  24.41. What is the difference between the highest and the lowest Value added (% of GDP) in 1963?
Your response must be concise. 26.96. 